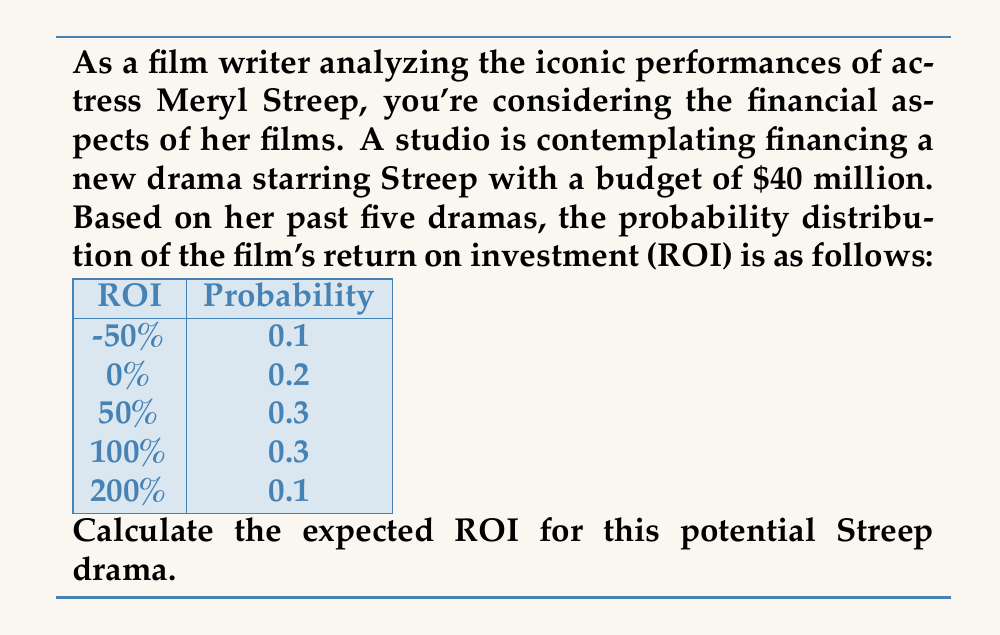Help me with this question. To calculate the expected ROI, we need to use the formula for expected value:

$$E(X) = \sum_{i=1}^{n} x_i \cdot p(x_i)$$

Where $x_i$ is each possible ROI value and $p(x_i)$ is its corresponding probability.

Let's calculate step by step:

1) For ROI = -50%:
   $-0.50 \cdot 0.1 = -0.05$

2) For ROI = 0%:
   $0 \cdot 0.2 = 0$

3) For ROI = 50%:
   $0.50 \cdot 0.3 = 0.15$

4) For ROI = 100%:
   $1 \cdot 0.3 = 0.3$

5) For ROI = 200%:
   $2 \cdot 0.1 = 0.2$

Now, sum all these values:

$$E(\text{ROI}) = -0.05 + 0 + 0.15 + 0.3 + 0.2 = 0.6$$

Therefore, the expected ROI is 0.6, or 60%.
Answer: 60% 